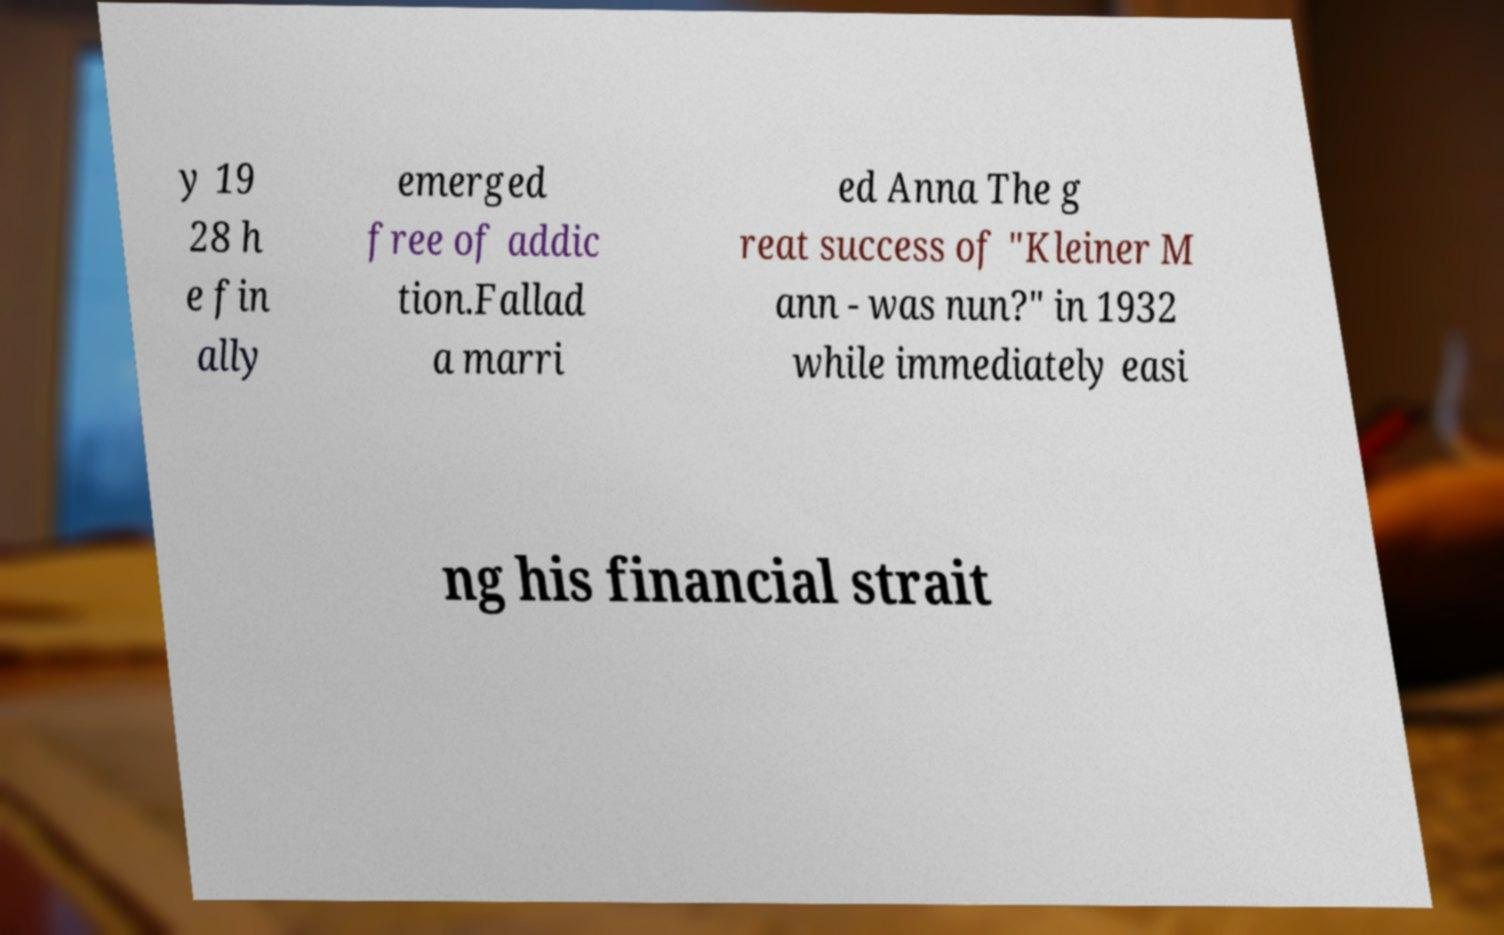There's text embedded in this image that I need extracted. Can you transcribe it verbatim? y 19 28 h e fin ally emerged free of addic tion.Fallad a marri ed Anna The g reat success of "Kleiner M ann - was nun?" in 1932 while immediately easi ng his financial strait 